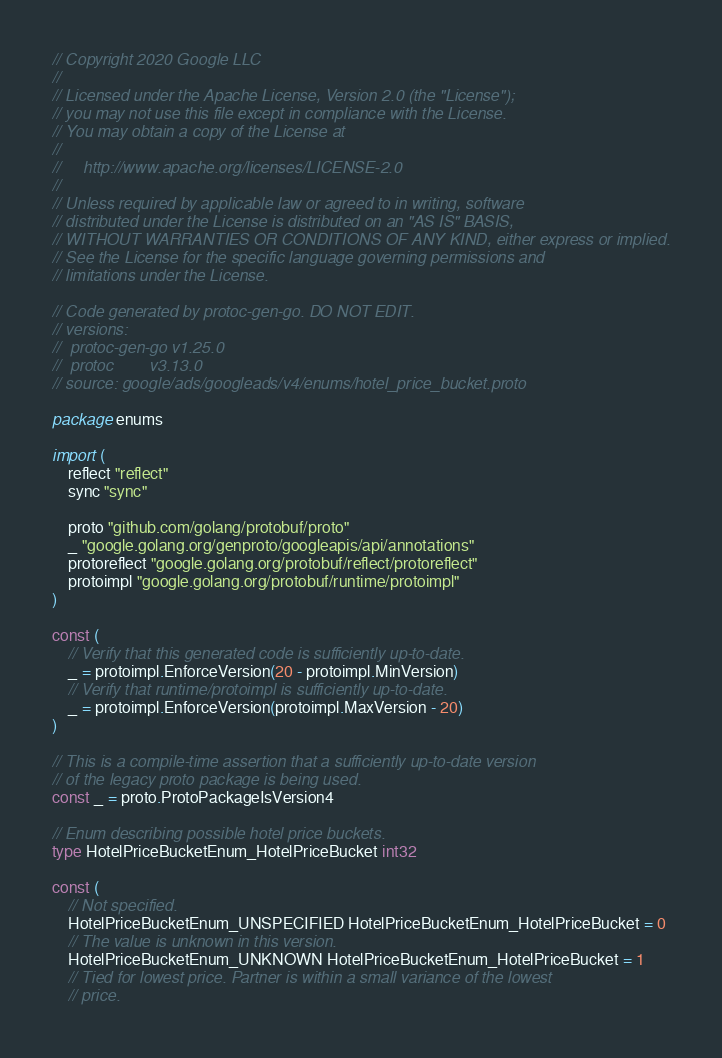Convert code to text. <code><loc_0><loc_0><loc_500><loc_500><_Go_>// Copyright 2020 Google LLC
//
// Licensed under the Apache License, Version 2.0 (the "License");
// you may not use this file except in compliance with the License.
// You may obtain a copy of the License at
//
//     http://www.apache.org/licenses/LICENSE-2.0
//
// Unless required by applicable law or agreed to in writing, software
// distributed under the License is distributed on an "AS IS" BASIS,
// WITHOUT WARRANTIES OR CONDITIONS OF ANY KIND, either express or implied.
// See the License for the specific language governing permissions and
// limitations under the License.

// Code generated by protoc-gen-go. DO NOT EDIT.
// versions:
// 	protoc-gen-go v1.25.0
// 	protoc        v3.13.0
// source: google/ads/googleads/v4/enums/hotel_price_bucket.proto

package enums

import (
	reflect "reflect"
	sync "sync"

	proto "github.com/golang/protobuf/proto"
	_ "google.golang.org/genproto/googleapis/api/annotations"
	protoreflect "google.golang.org/protobuf/reflect/protoreflect"
	protoimpl "google.golang.org/protobuf/runtime/protoimpl"
)

const (
	// Verify that this generated code is sufficiently up-to-date.
	_ = protoimpl.EnforceVersion(20 - protoimpl.MinVersion)
	// Verify that runtime/protoimpl is sufficiently up-to-date.
	_ = protoimpl.EnforceVersion(protoimpl.MaxVersion - 20)
)

// This is a compile-time assertion that a sufficiently up-to-date version
// of the legacy proto package is being used.
const _ = proto.ProtoPackageIsVersion4

// Enum describing possible hotel price buckets.
type HotelPriceBucketEnum_HotelPriceBucket int32

const (
	// Not specified.
	HotelPriceBucketEnum_UNSPECIFIED HotelPriceBucketEnum_HotelPriceBucket = 0
	// The value is unknown in this version.
	HotelPriceBucketEnum_UNKNOWN HotelPriceBucketEnum_HotelPriceBucket = 1
	// Tied for lowest price. Partner is within a small variance of the lowest
	// price.</code> 